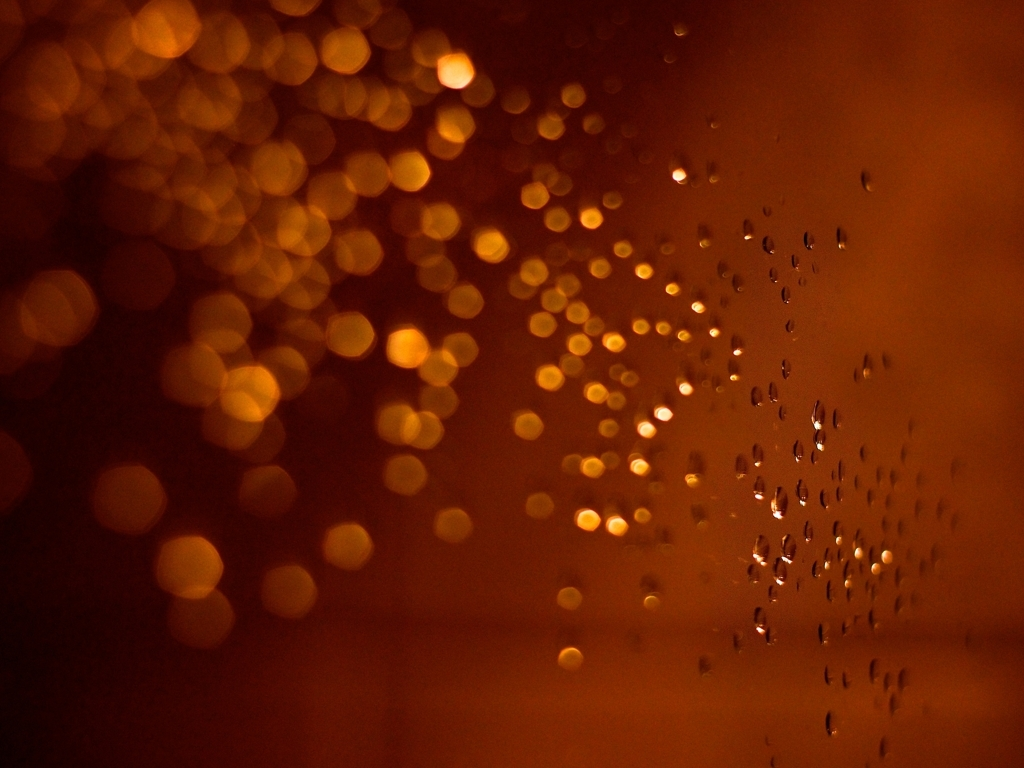Are there any artifacts present in the image?
A. No
B. Yes
C. None
Answer with the option's letter from the given choices directly.
 B. 